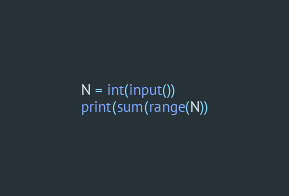<code> <loc_0><loc_0><loc_500><loc_500><_Python_>N = int(input())
print(sum(range(N))</code> 